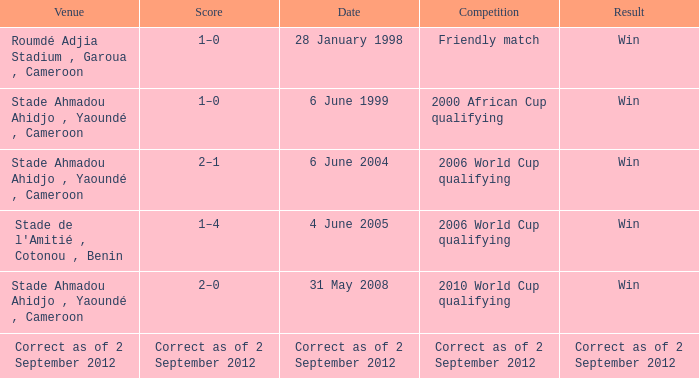What was the result for a friendly match? Win. 